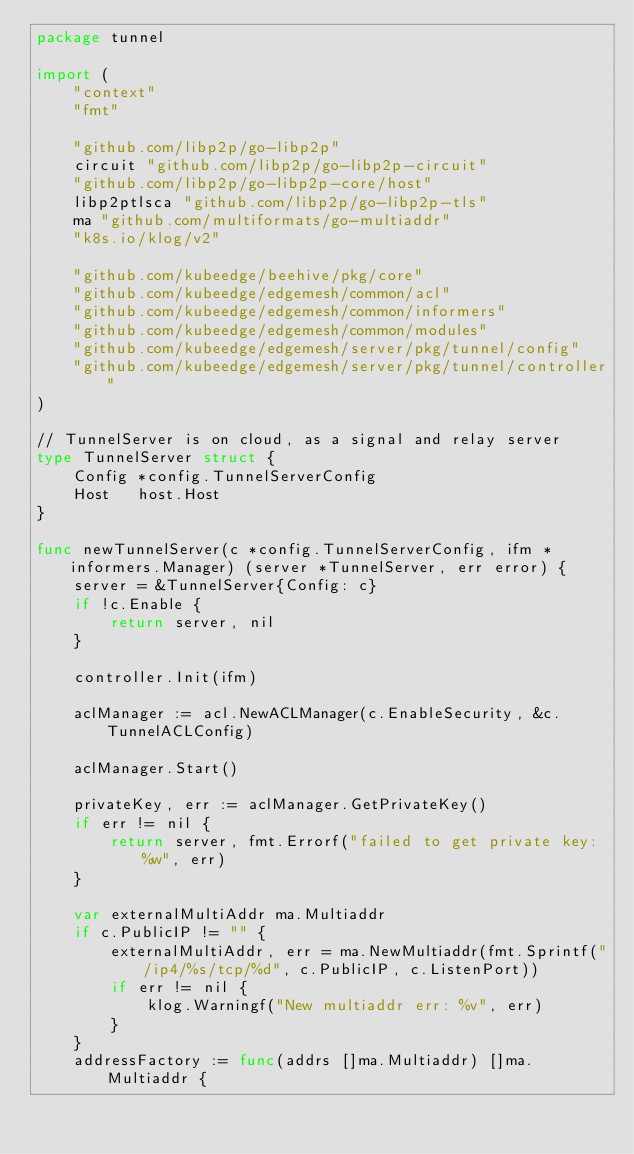<code> <loc_0><loc_0><loc_500><loc_500><_Go_>package tunnel

import (
	"context"
	"fmt"

	"github.com/libp2p/go-libp2p"
	circuit "github.com/libp2p/go-libp2p-circuit"
	"github.com/libp2p/go-libp2p-core/host"
	libp2ptlsca "github.com/libp2p/go-libp2p-tls"
	ma "github.com/multiformats/go-multiaddr"
	"k8s.io/klog/v2"

	"github.com/kubeedge/beehive/pkg/core"
	"github.com/kubeedge/edgemesh/common/acl"
	"github.com/kubeedge/edgemesh/common/informers"
	"github.com/kubeedge/edgemesh/common/modules"
	"github.com/kubeedge/edgemesh/server/pkg/tunnel/config"
	"github.com/kubeedge/edgemesh/server/pkg/tunnel/controller"
)

// TunnelServer is on cloud, as a signal and relay server
type TunnelServer struct {
	Config *config.TunnelServerConfig
	Host   host.Host
}

func newTunnelServer(c *config.TunnelServerConfig, ifm *informers.Manager) (server *TunnelServer, err error) {
	server = &TunnelServer{Config: c}
	if !c.Enable {
		return server, nil
	}

	controller.Init(ifm)

	aclManager := acl.NewACLManager(c.EnableSecurity, &c.TunnelACLConfig)

	aclManager.Start()

	privateKey, err := aclManager.GetPrivateKey()
	if err != nil {
		return server, fmt.Errorf("failed to get private key: %w", err)
	}

	var externalMultiAddr ma.Multiaddr
	if c.PublicIP != "" {
		externalMultiAddr, err = ma.NewMultiaddr(fmt.Sprintf("/ip4/%s/tcp/%d", c.PublicIP, c.ListenPort))
		if err != nil {
			klog.Warningf("New multiaddr err: %v", err)
		}
	}
	addressFactory := func(addrs []ma.Multiaddr) []ma.Multiaddr {</code> 